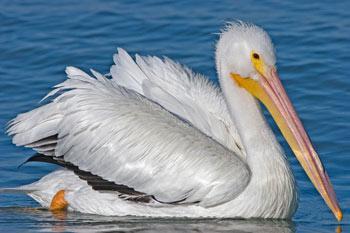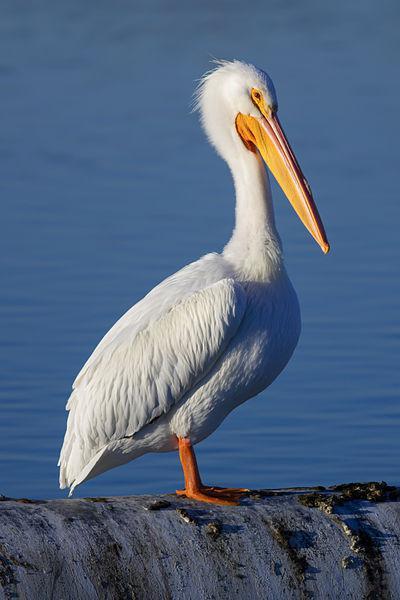The first image is the image on the left, the second image is the image on the right. Considering the images on both sides, is "At least one bird is standing, not swimming." valid? Answer yes or no. Yes. 